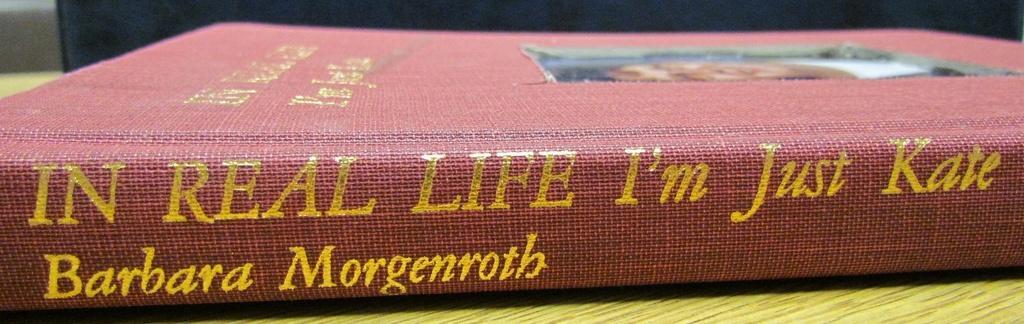Please provide a concise description of this image. In this picture, we can see the book with some text on it, and the book is on an object, we can see the background. 